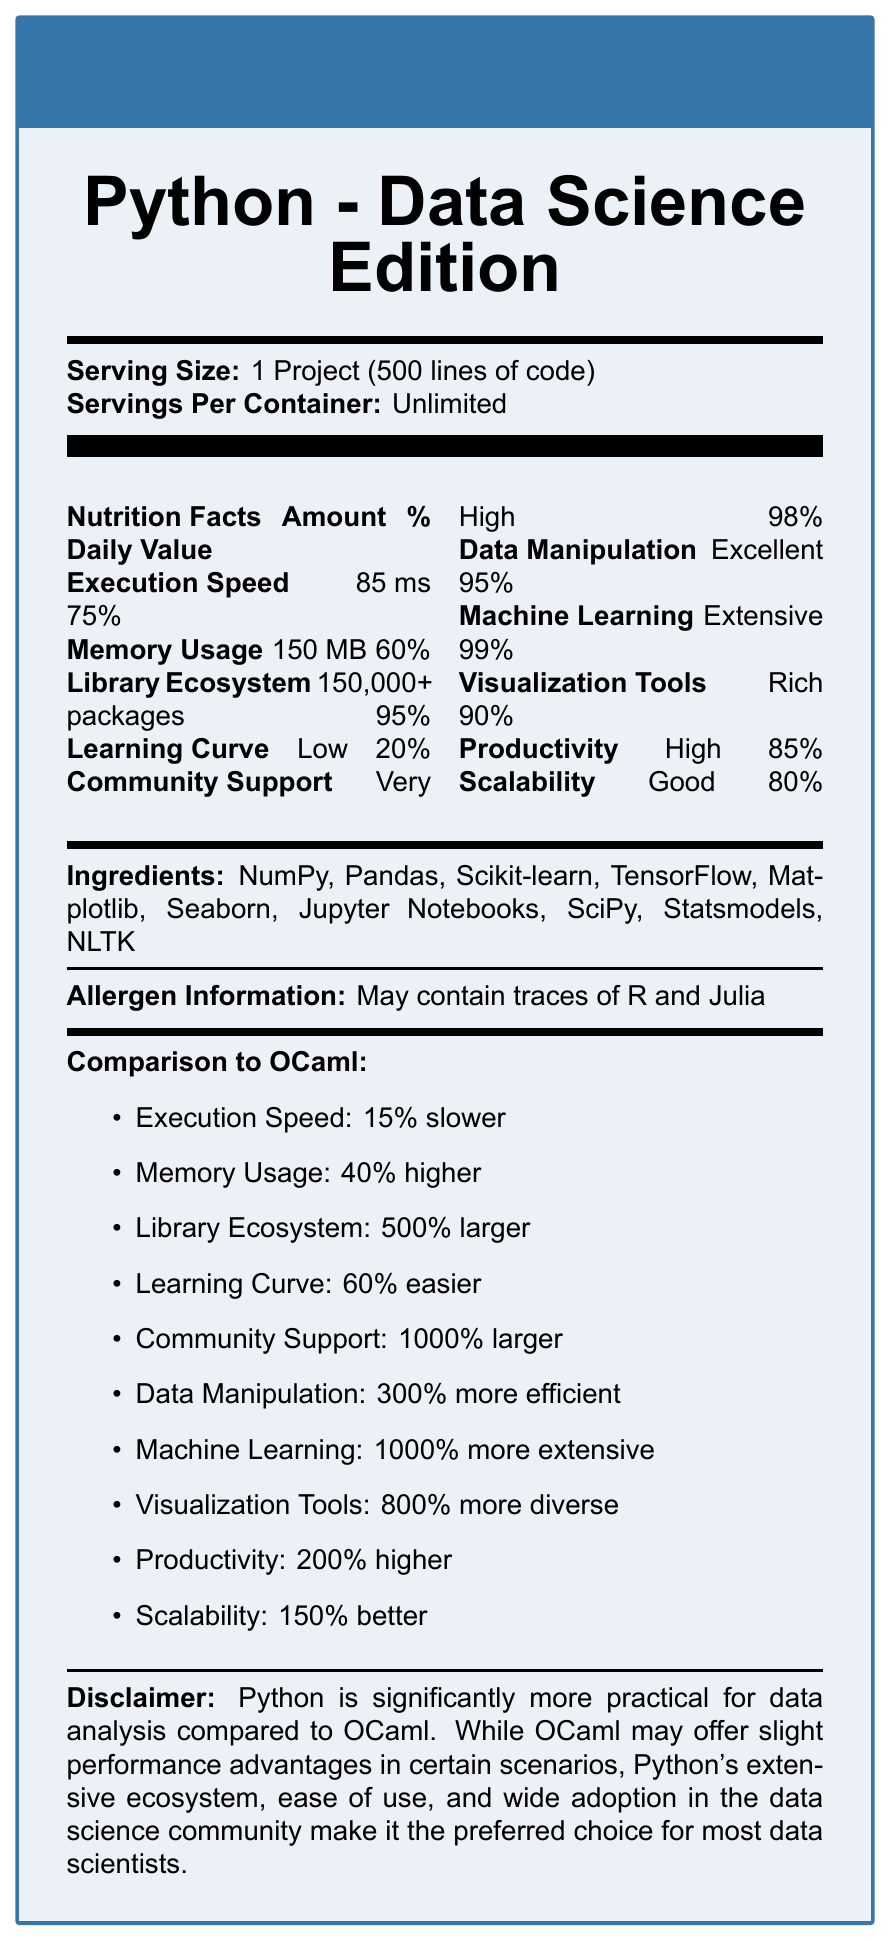what is the product name? The product name is clearly stated at the beginning of the document: "Python - Data Science Edition."
Answer: Python - Data Science Edition what is the serving size of the product? The serving size is mentioned at the top of the document under "Serving Size."
Answer: 1 Project (500 lines of code) how many servings are there per container? The "Servings Per Container" section specifies that the servings are unlimited.
Answer: Unlimited what is the execution speed of this product? The execution speed is listed under the "Nutrition Facts" section as "85 ms."
Answer: 85 ms what percent daily value does the library ecosystem of the product have? The library ecosystem's percent daily value is stated as 95%.
Answer: 95% how does the community support of Python compare to OCaml? In the "Comparison to OCaml" section, it is mentioned that the community support of Python is 1000% larger than OCaml's.
Answer: 1000% larger how much faster is OCaml's execution speed compared to Python? The document states that Python's execution speed is 15% slower, implying that OCaml is 15% faster.
Answer: 15% faster which of the following is not an ingredient of Python - Data Science Edition? A. NumPy B. Pandas C. Haskell D. TensorFlow The document lists the ingredients, and Haskell is not included among them.
Answer: C. Haskell what is the difference in memory usage between Python and OCaml? The document states that Python’s memory usage is 40% higher compared to OCaml.
Answer: 40% higher in Python what percentage daily value does productivity have? A. 75% B. 85% C. 90% The document states that productivity's percentage daily value is 85%, making B the correct option.
Answer: B. 85% does the document indicate that OCaml has a larger library ecosystem than Python? The "Comparison to OCaml" section clearly states that Python's library ecosystem is 500% larger than OCaml's.
Answer: No are the learning curves of Python and OCaml similar according to the document? The document mentions that Python has a 60% easier learning curve than OCaml.
Answer: No summarize the main idea of the document. The document provides a detailed comparison between Python and OCaml concerning various aspects such as execution speed, memory usage, library ecosystem, and other attributes, highlighting Python's advantages in the data science field.
Answer: Python is significantly more practical for data analysis compared to OCaml, with its extensive ecosystem, ease of use, community support, and comprehensive toolset making it the preferred choice for data scientists. is Python's data manipulation capability better than OCaml according to the document? The document states that Python's data manipulation is 300% more efficient than OCaml's.
Answer: Yes which ingredient is not primarily used for machine learning tasks? A. TensorFlow B. Scikit-learn C. Matplotlib D. Pandas TensorFlow and Scikit-learn are specifically for machine learning, and Pandas is for data manipulation, while Matplotlib is primarily for visualization.
Answer: C. Matplotlib how does Python's scalability compare to OCaml's? The comparison section states that Python's scalability is 150% better than OCaml's.
Answer: 150% better in the document: what is the allergen information? The allergen information section states that the product may contain traces of R and Julia.
Answer: May contain traces of R and Julia can the exact memory usage of OCaml be determined from the document? The document only provides the relative difference, stating that Python's memory usage is 40% higher, but does not provide the exact memory usage of OCaml.
Answer: Cannot be determined 